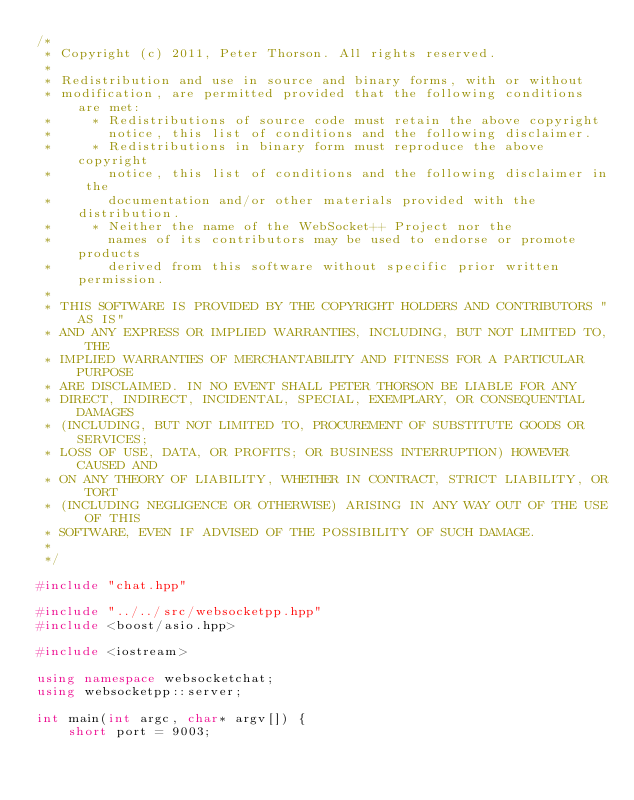Convert code to text. <code><loc_0><loc_0><loc_500><loc_500><_C++_>/*
 * Copyright (c) 2011, Peter Thorson. All rights reserved.
 *
 * Redistribution and use in source and binary forms, with or without
 * modification, are permitted provided that the following conditions are met:
 *     * Redistributions of source code must retain the above copyright
 *       notice, this list of conditions and the following disclaimer.
 *     * Redistributions in binary form must reproduce the above copyright
 *       notice, this list of conditions and the following disclaimer in the
 *       documentation and/or other materials provided with the distribution.
 *     * Neither the name of the WebSocket++ Project nor the
 *       names of its contributors may be used to endorse or promote products
 *       derived from this software without specific prior written permission.
 * 
 * THIS SOFTWARE IS PROVIDED BY THE COPYRIGHT HOLDERS AND CONTRIBUTORS "AS IS" 
 * AND ANY EXPRESS OR IMPLIED WARRANTIES, INCLUDING, BUT NOT LIMITED TO, THE 
 * IMPLIED WARRANTIES OF MERCHANTABILITY AND FITNESS FOR A PARTICULAR PURPOSE 
 * ARE DISCLAIMED. IN NO EVENT SHALL PETER THORSON BE LIABLE FOR ANY
 * DIRECT, INDIRECT, INCIDENTAL, SPECIAL, EXEMPLARY, OR CONSEQUENTIAL DAMAGES
 * (INCLUDING, BUT NOT LIMITED TO, PROCUREMENT OF SUBSTITUTE GOODS OR SERVICES;
 * LOSS OF USE, DATA, OR PROFITS; OR BUSINESS INTERRUPTION) HOWEVER CAUSED AND
 * ON ANY THEORY OF LIABILITY, WHETHER IN CONTRACT, STRICT LIABILITY, OR TORT
 * (INCLUDING NEGLIGENCE OR OTHERWISE) ARISING IN ANY WAY OUT OF THE USE OF THIS
 * SOFTWARE, EVEN IF ADVISED OF THE POSSIBILITY OF SUCH DAMAGE.
 * 
 */

#include "chat.hpp"

#include "../../src/websocketpp.hpp"
#include <boost/asio.hpp>

#include <iostream>

using namespace websocketchat;
using websocketpp::server;

int main(int argc, char* argv[]) {
    short port = 9003;</code> 